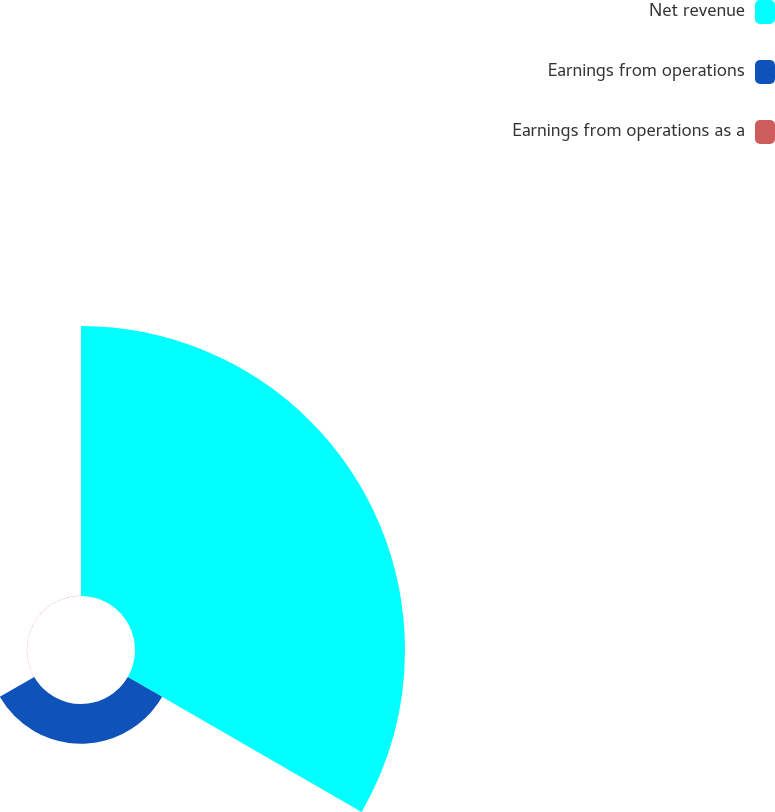Convert chart. <chart><loc_0><loc_0><loc_500><loc_500><pie_chart><fcel>Net revenue<fcel>Earnings from operations<fcel>Earnings from operations as a<nl><fcel>87.12%<fcel>12.82%<fcel>0.05%<nl></chart> 